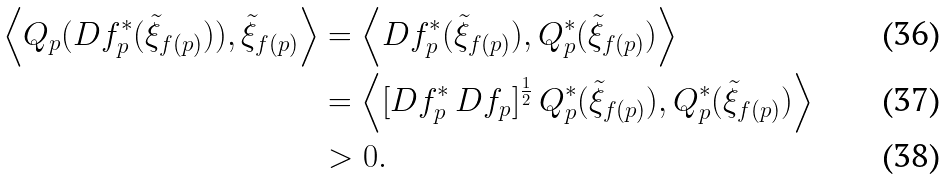<formula> <loc_0><loc_0><loc_500><loc_500>\left \langle Q _ { p } ( D f _ { p } ^ { * } ( \tilde { \xi } _ { f ( p ) } ) ) , \tilde { \xi } _ { f ( p ) } \right \rangle & = \left \langle D f _ { p } ^ { * } ( \tilde { \xi } _ { f ( p ) } ) , Q _ { p } ^ { * } ( \tilde { \xi } _ { f ( p ) } ) \right \rangle \\ & = \left \langle [ D f _ { p } ^ { * } \, D f _ { p } ] ^ { \frac { 1 } { 2 } } \, Q _ { p } ^ { * } ( \tilde { \xi } _ { f ( p ) } ) , Q _ { p } ^ { * } ( \tilde { \xi } _ { f ( p ) } ) \right \rangle \\ & > 0 .</formula> 